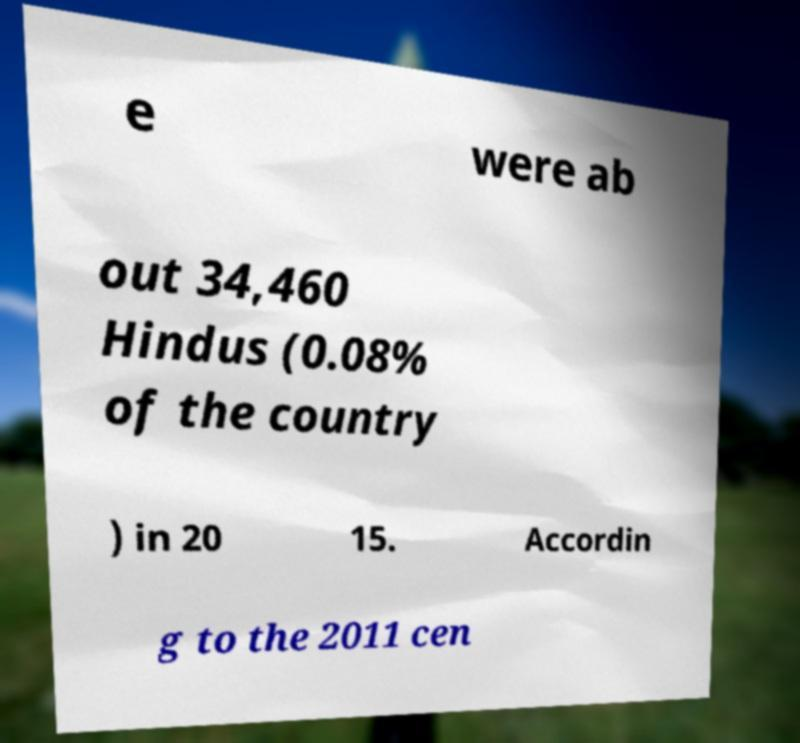Could you assist in decoding the text presented in this image and type it out clearly? e were ab out 34,460 Hindus (0.08% of the country ) in 20 15. Accordin g to the 2011 cen 